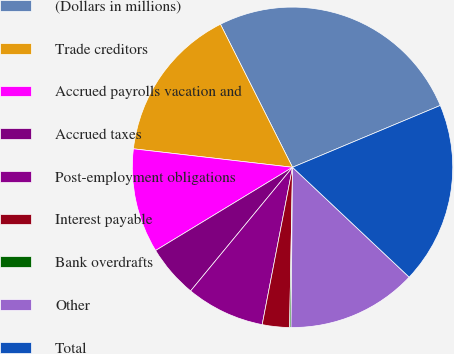Convert chart. <chart><loc_0><loc_0><loc_500><loc_500><pie_chart><fcel>(Dollars in millions)<fcel>Trade creditors<fcel>Accrued payrolls vacation and<fcel>Accrued taxes<fcel>Post-employment obligations<fcel>Interest payable<fcel>Bank overdrafts<fcel>Other<fcel>Total<nl><fcel>26.12%<fcel>15.73%<fcel>10.53%<fcel>5.34%<fcel>7.94%<fcel>2.74%<fcel>0.14%<fcel>13.13%<fcel>18.33%<nl></chart> 